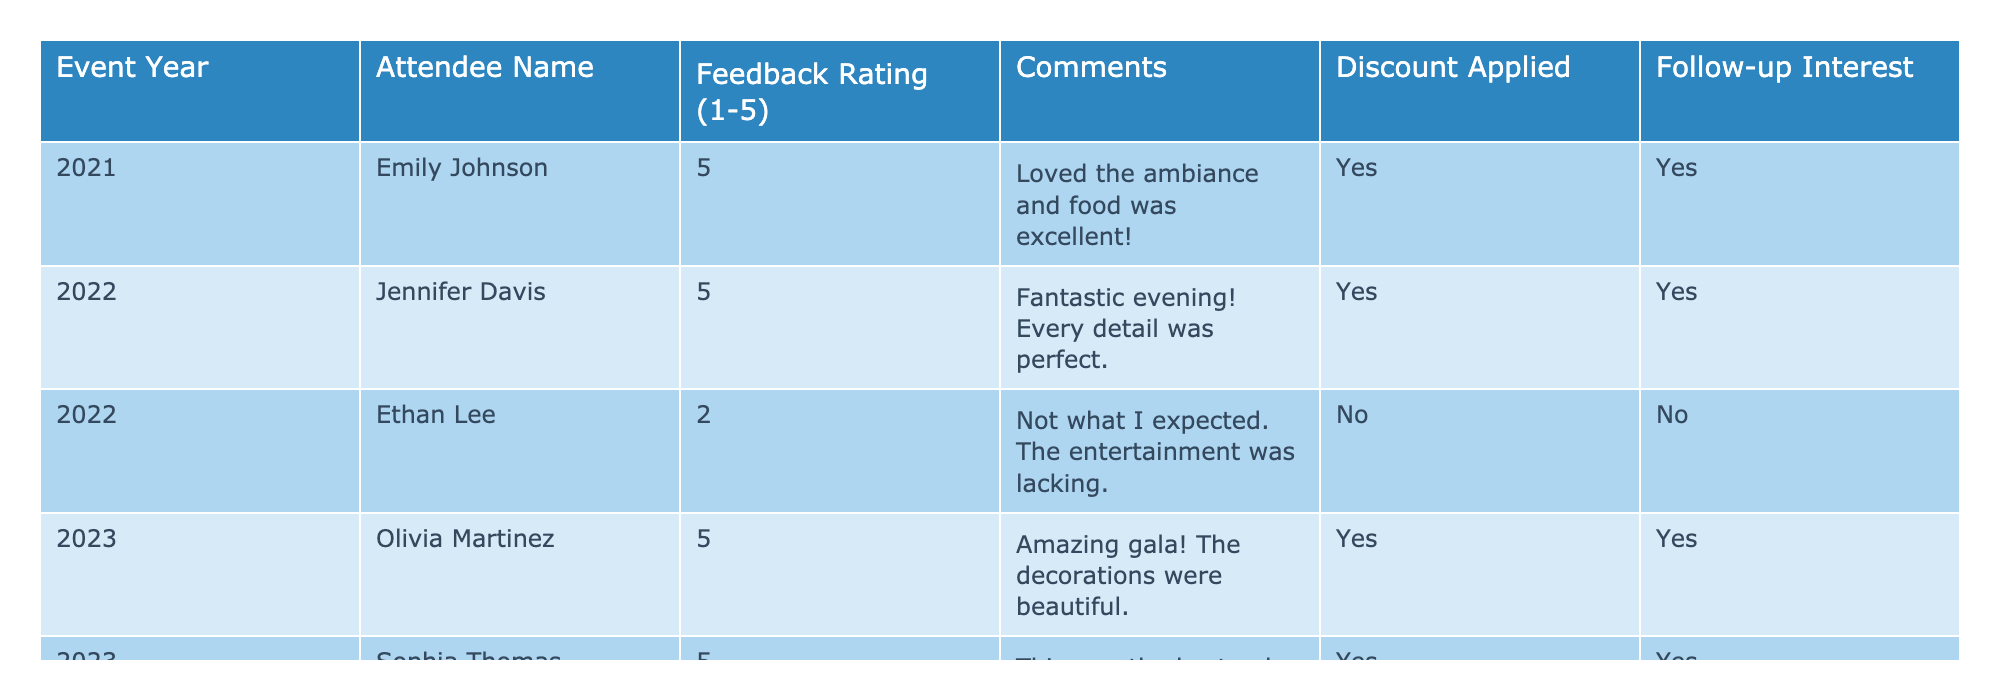What was the highest feedback rating given in 2023? The table shows that both Olivia Martinez and Sophia Thomas gave a rating of 5 in 2023, which is the highest possible feedback rating.
Answer: 5 How many attendees rated the gala a 2 in 2022? According to the table, there is only one attendee, Ethan Lee, who rated the gala a 2 in 2022.
Answer: 1 What percentage of attendees applied for a discount in 2023? The total number of attendees in 2023 is 2 (Olivia and Sophia), both of whom applied for a discount (100%). To find the percentage, (2/2) * 100 = 100%.
Answer: 100% Was there any attendee in 2021 who did not express interest in a follow-up? The table shows that Emily Johnson, who attended in 2021, expressed interest in a follow-up, meaning there were no attendees from that year who declined.
Answer: No How do the average feedback ratings compare between 2021 and 2022? In 2021, Emily Johnson rated the gala a 5. In 2022, Jennifer Davis rated it a 5 and Ethan Lee a 2. The average for 2021 is 5, while for 2022 it is (5 + 2) / 2 = 3.5, indicating 2021 had a higher average rating.
Answer: 2021 is higher Which event year had the most attendees who applied for a discount? The table shows that all attendees in 2021 (1), 2022 (1 out of 2), and 2023 (2) applied for a discount. Consequently, 2023 had the most attendees applying for a discount with 2.
Answer: 2023 What do the comments for the attendees who rated the event a 5 have in common? The comments from attendees with a rating of 5 highlight positive aspects, such as excellent ambiance, perfection in details, and beautiful decorations, indicating overall satisfaction with the event.
Answer: Positive feedback How many attendees expressed interest in a follow-up after rating the event a 2? From the table, Ethan Lee rated the event a 2 in 2022 and did not express interest in a follow-up. Thus, the answer is zero attendees.
Answer: 0 